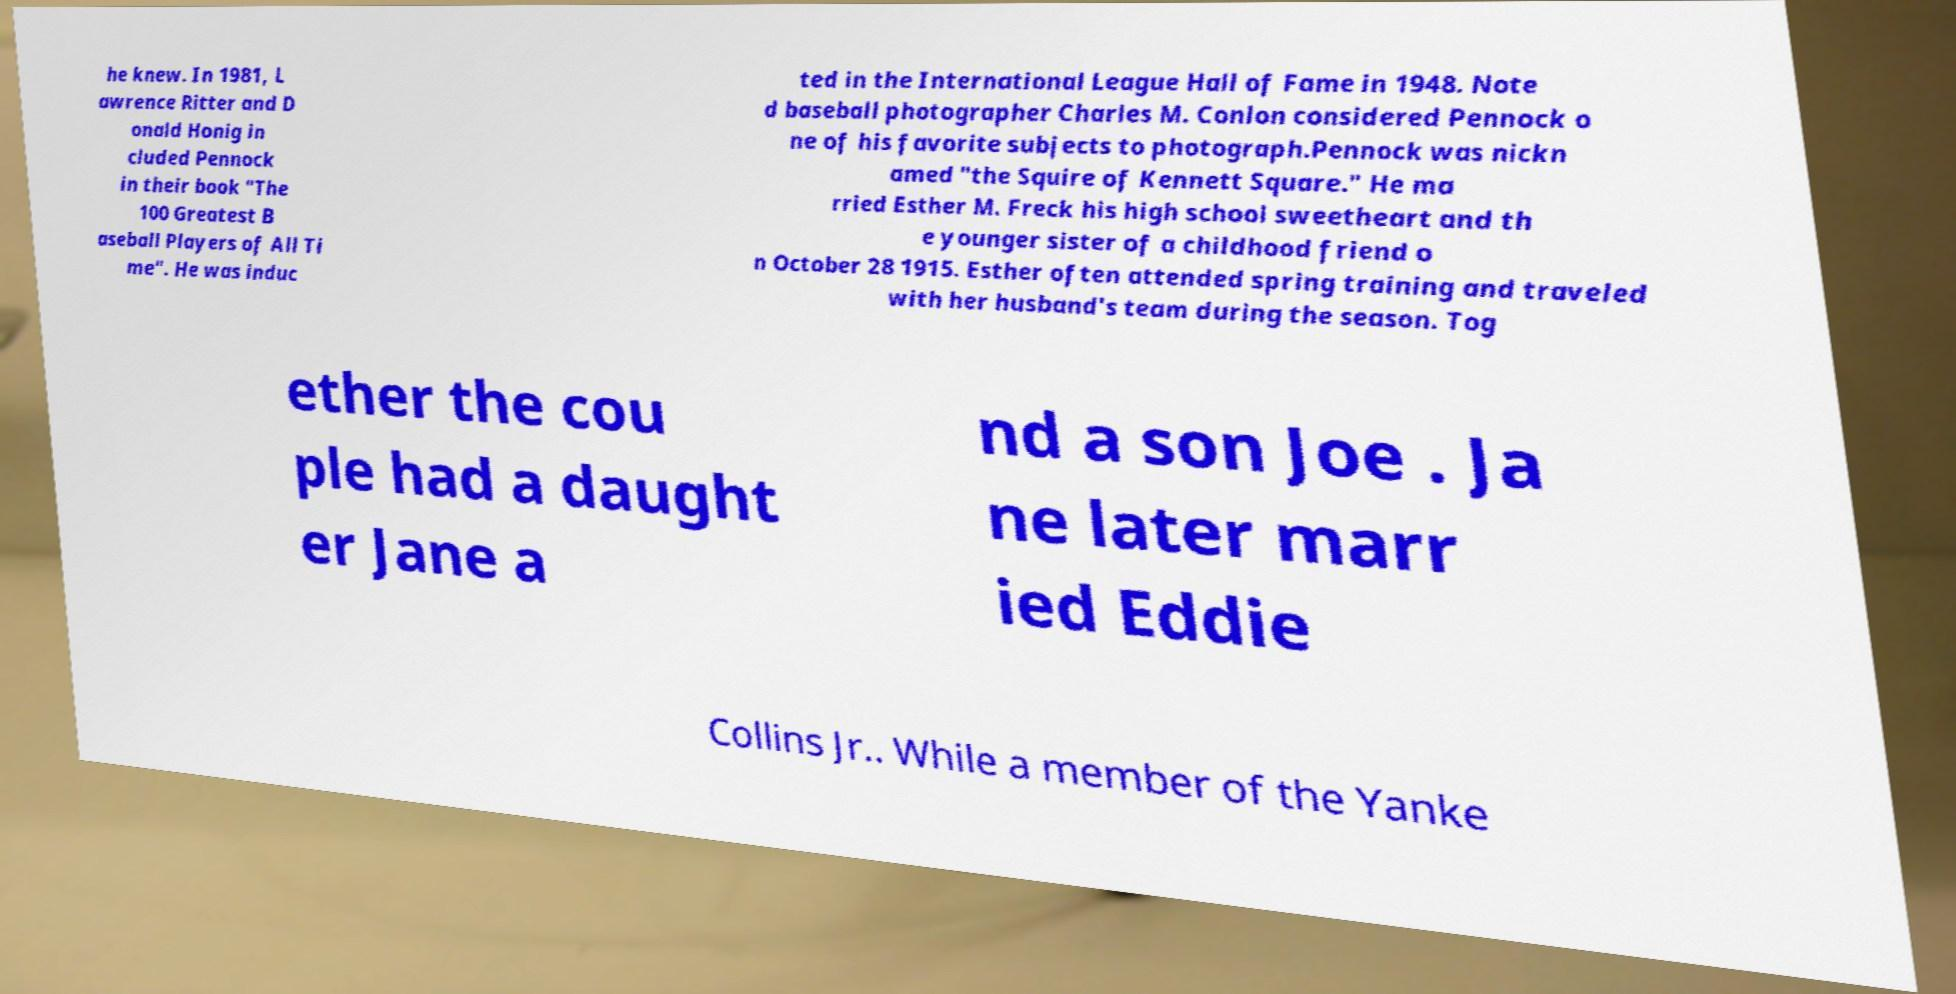What messages or text are displayed in this image? I need them in a readable, typed format. he knew. In 1981, L awrence Ritter and D onald Honig in cluded Pennock in their book "The 100 Greatest B aseball Players of All Ti me". He was induc ted in the International League Hall of Fame in 1948. Note d baseball photographer Charles M. Conlon considered Pennock o ne of his favorite subjects to photograph.Pennock was nickn amed "the Squire of Kennett Square." He ma rried Esther M. Freck his high school sweetheart and th e younger sister of a childhood friend o n October 28 1915. Esther often attended spring training and traveled with her husband's team during the season. Tog ether the cou ple had a daught er Jane a nd a son Joe . Ja ne later marr ied Eddie Collins Jr.. While a member of the Yanke 